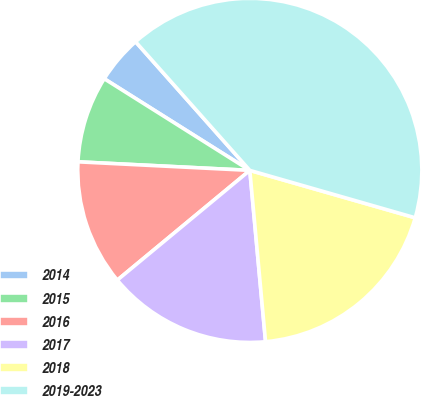Convert chart. <chart><loc_0><loc_0><loc_500><loc_500><pie_chart><fcel>2014<fcel>2015<fcel>2016<fcel>2017<fcel>2018<fcel>2019-2023<nl><fcel>4.5%<fcel>8.15%<fcel>11.8%<fcel>15.45%<fcel>19.1%<fcel>41.0%<nl></chart> 